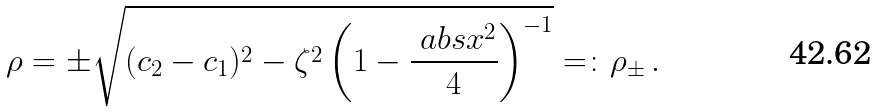<formula> <loc_0><loc_0><loc_500><loc_500>\rho = \pm \sqrt { ( c _ { 2 } - c _ { 1 } ) ^ { 2 } - \zeta ^ { 2 } \left ( 1 - \frac { \ a b s { x } ^ { 2 } } { 4 } \right ) ^ { - 1 } } = \colon \rho _ { \pm } \, .</formula> 